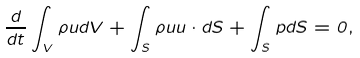<formula> <loc_0><loc_0><loc_500><loc_500>\frac { d } { d t } \int _ { V } \rho { u } d V + \int _ { S } \rho { u } { u } \cdot d { S } + \int _ { S } p d { S } = 0 ,</formula> 